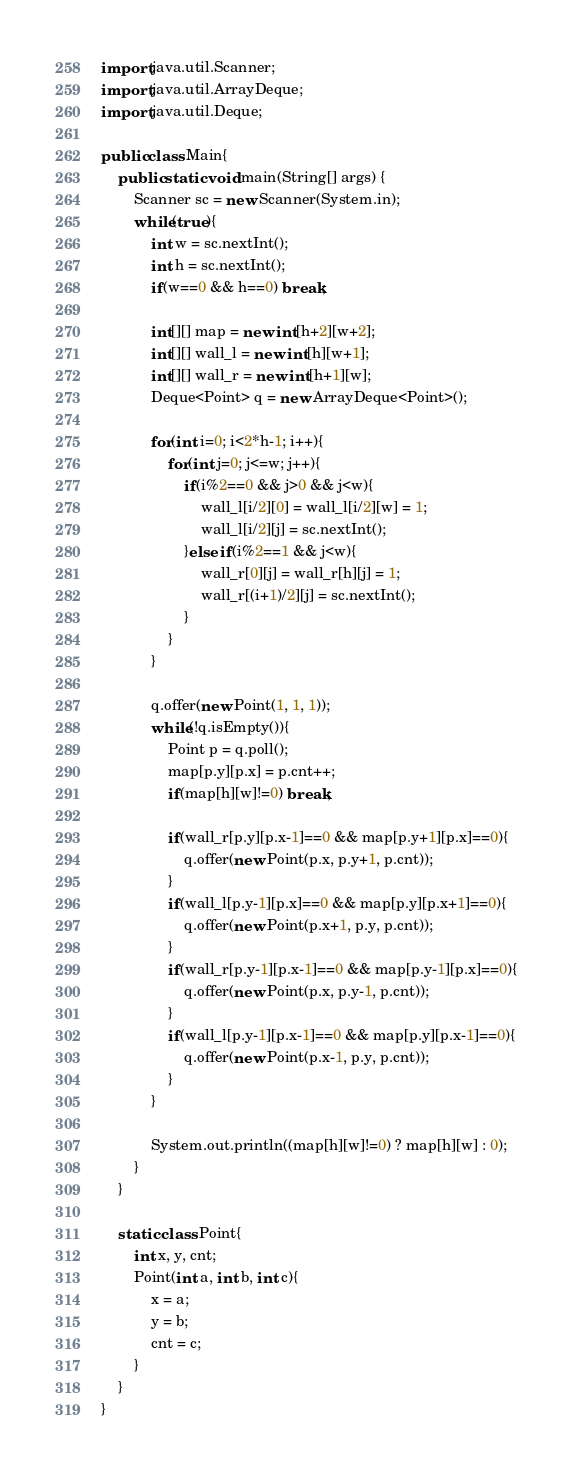<code> <loc_0><loc_0><loc_500><loc_500><_Java_>import java.util.Scanner;
import java.util.ArrayDeque;
import java.util.Deque;

public class Main{
	public static void main(String[] args) {
		Scanner sc = new Scanner(System.in);
		while(true){
			int w = sc.nextInt();
			int h = sc.nextInt();
			if(w==0 && h==0) break;

			int[][] map = new int[h+2][w+2];
			int[][] wall_l = new int[h][w+1];
			int[][] wall_r = new int[h+1][w];
			Deque<Point> q = new ArrayDeque<Point>();

			for(int i=0; i<2*h-1; i++){
				for(int j=0; j<=w; j++){
					if(i%2==0 && j>0 && j<w){
						wall_l[i/2][0] = wall_l[i/2][w] = 1;
						wall_l[i/2][j] = sc.nextInt();
					}else if(i%2==1 && j<w){
						wall_r[0][j] = wall_r[h][j] = 1;
						wall_r[(i+1)/2][j] = sc.nextInt();
					}
				}
			}

			q.offer(new Point(1, 1, 1));
			while(!q.isEmpty()){
				Point p = q.poll();
				map[p.y][p.x] = p.cnt++;
				if(map[h][w]!=0) break;

				if(wall_r[p.y][p.x-1]==0 && map[p.y+1][p.x]==0){
					q.offer(new Point(p.x, p.y+1, p.cnt));
				}
				if(wall_l[p.y-1][p.x]==0 && map[p.y][p.x+1]==0){
					q.offer(new Point(p.x+1, p.y, p.cnt));
				}
				if(wall_r[p.y-1][p.x-1]==0 && map[p.y-1][p.x]==0){
					q.offer(new Point(p.x, p.y-1, p.cnt));
				}
				if(wall_l[p.y-1][p.x-1]==0 && map[p.y][p.x-1]==0){
					q.offer(new Point(p.x-1, p.y, p.cnt));
				}
			}

			System.out.println((map[h][w]!=0) ? map[h][w] : 0);
		}
	}

	static class Point{
		int x, y, cnt;
		Point(int a, int b, int c){
			x = a;
			y = b;
			cnt = c;
		}
	}
}</code> 